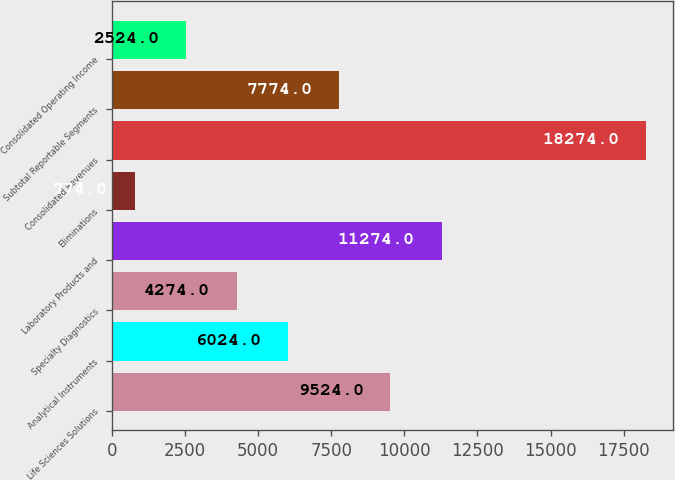<chart> <loc_0><loc_0><loc_500><loc_500><bar_chart><fcel>Life Sciences Solutions<fcel>Analytical Instruments<fcel>Specialty Diagnostics<fcel>Laboratory Products and<fcel>Eliminations<fcel>Consolidated Revenues<fcel>Subtotal Reportable Segments<fcel>Consolidated Operating Income<nl><fcel>9524<fcel>6024<fcel>4274<fcel>11274<fcel>774<fcel>18274<fcel>7774<fcel>2524<nl></chart> 